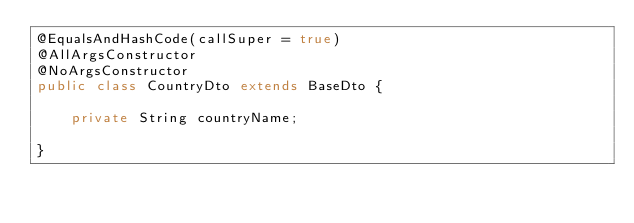Convert code to text. <code><loc_0><loc_0><loc_500><loc_500><_Java_>@EqualsAndHashCode(callSuper = true)
@AllArgsConstructor
@NoArgsConstructor
public class CountryDto extends BaseDto {

    private String countryName;

}
</code> 